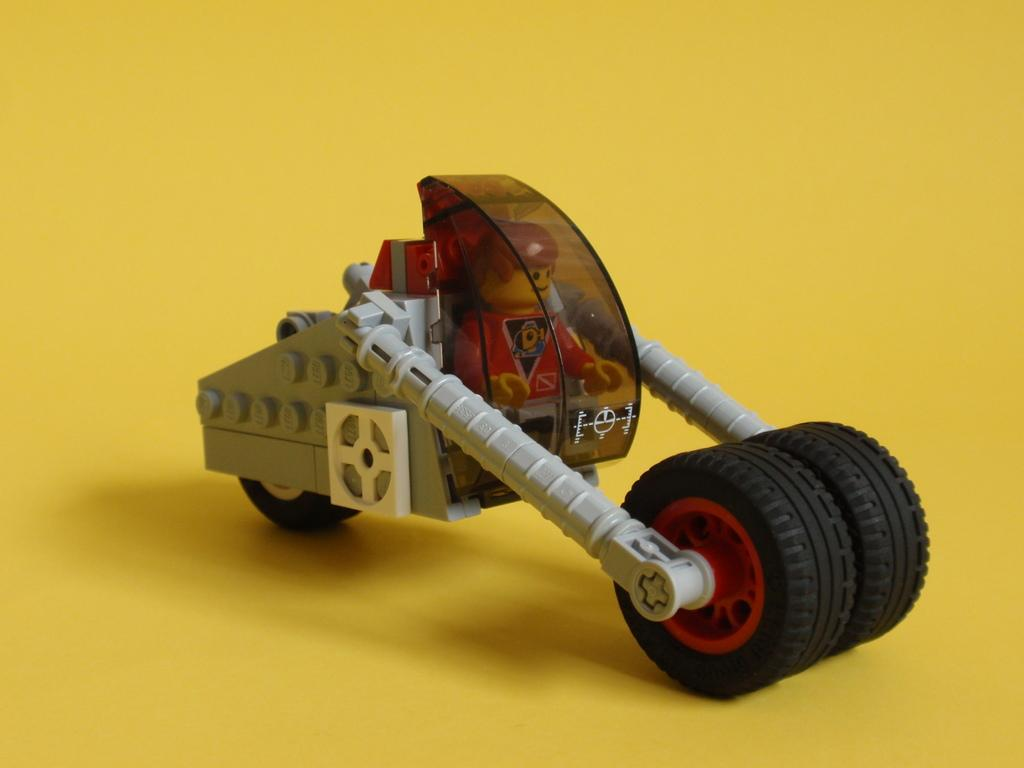What object can be seen in the image? There is a toy in the image. What color is the background of the image? The background of the image is yellow. What type of bone is visible in the image? There is no bone present in the image; it only features a toy and a yellow background. 